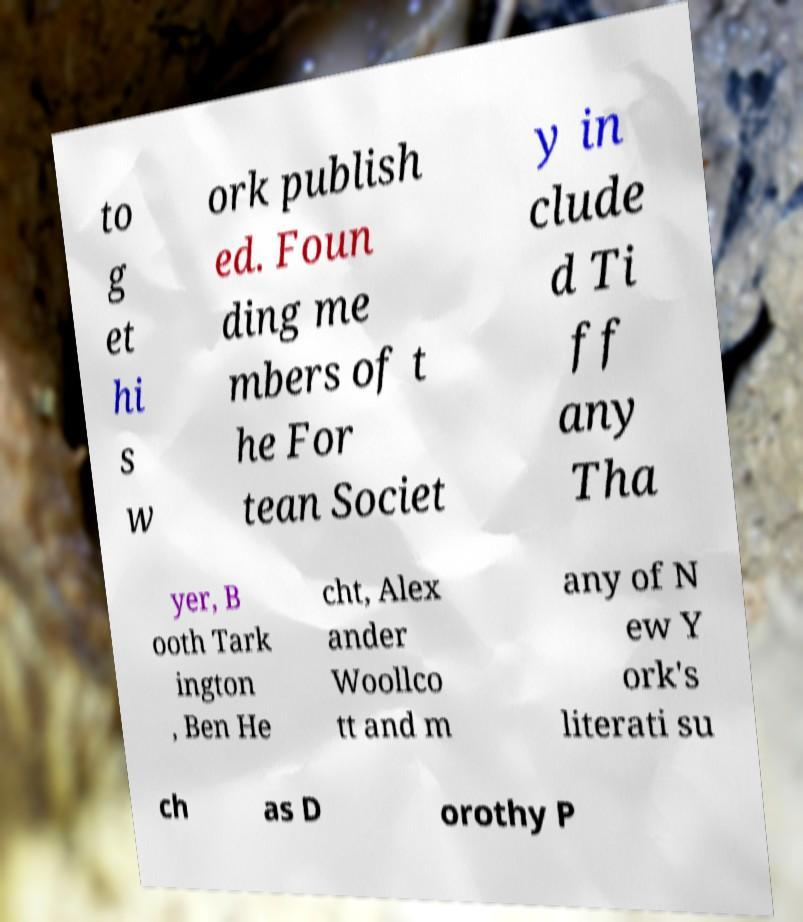Please identify and transcribe the text found in this image. to g et hi s w ork publish ed. Foun ding me mbers of t he For tean Societ y in clude d Ti ff any Tha yer, B ooth Tark ington , Ben He cht, Alex ander Woollco tt and m any of N ew Y ork's literati su ch as D orothy P 